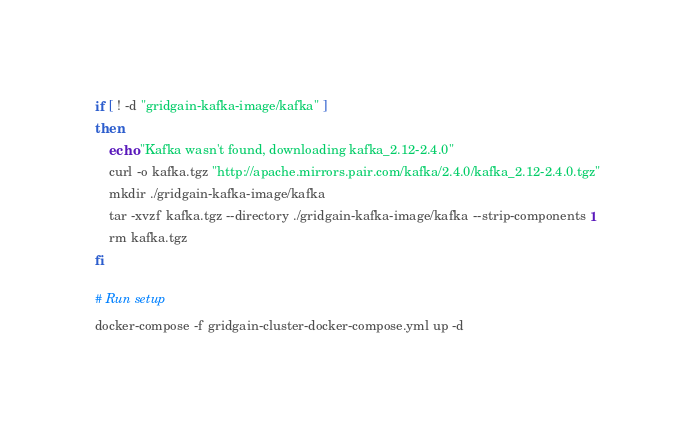<code> <loc_0><loc_0><loc_500><loc_500><_Bash_>if [ ! -d "gridgain-kafka-image/kafka" ]
then
	echo "Kafka wasn't found, downloading kafka_2.12-2.4.0"
	curl -o kafka.tgz "http://apache.mirrors.pair.com/kafka/2.4.0/kafka_2.12-2.4.0.tgz"
	mkdir ./gridgain-kafka-image/kafka
	tar -xvzf kafka.tgz --directory ./gridgain-kafka-image/kafka --strip-components 1
	rm kafka.tgz
fi

# Run setup
docker-compose -f gridgain-cluster-docker-compose.yml up -d
</code> 